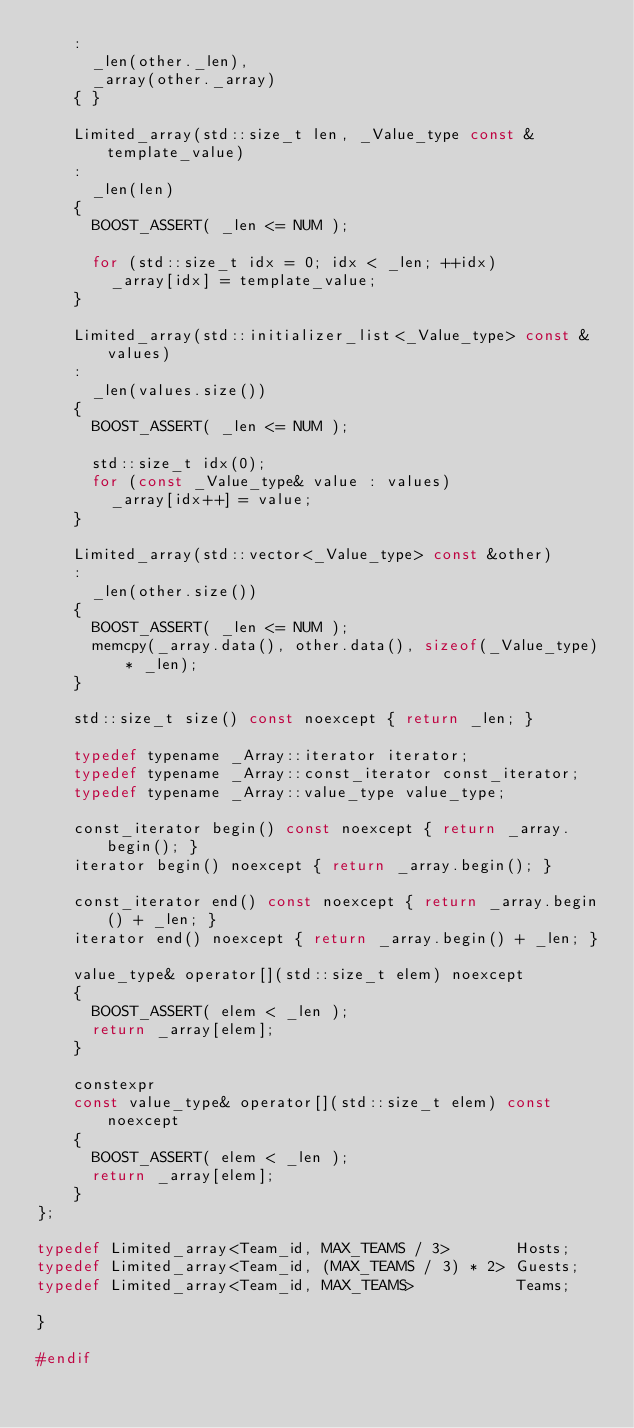Convert code to text. <code><loc_0><loc_0><loc_500><loc_500><_C_>		:
			_len(other._len),
			_array(other._array)
		{ }

		Limited_array(std::size_t len, _Value_type const &template_value)
		:
			_len(len)
		{
			BOOST_ASSERT( _len <= NUM );

			for (std::size_t idx = 0; idx < _len; ++idx)
				_array[idx] = template_value;
		}

		Limited_array(std::initializer_list<_Value_type> const &values)
		:
			_len(values.size())
		{
			BOOST_ASSERT( _len <= NUM );

			std::size_t idx(0);
			for (const _Value_type& value : values)
				_array[idx++] = value;
		}

		Limited_array(std::vector<_Value_type> const &other)
		:
			_len(other.size())
		{
			BOOST_ASSERT( _len <= NUM );
			memcpy(_array.data(), other.data(), sizeof(_Value_type) * _len);
		}

		std::size_t size() const noexcept { return _len; }

		typedef typename _Array::iterator iterator;
		typedef typename _Array::const_iterator const_iterator;
		typedef typename _Array::value_type value_type;

		const_iterator begin() const noexcept { return _array.begin(); }
		iterator begin() noexcept { return _array.begin(); }

		const_iterator end() const noexcept { return _array.begin() + _len; }
		iterator end() noexcept { return _array.begin() + _len; }

		value_type& operator[](std::size_t elem) noexcept
		{
			BOOST_ASSERT( elem < _len );
			return _array[elem];
		}

		constexpr
		const value_type& operator[](std::size_t elem) const noexcept
		{
			BOOST_ASSERT( elem < _len );
			return _array[elem];
		}
};

typedef Limited_array<Team_id, MAX_TEAMS / 3>       Hosts;
typedef Limited_array<Team_id, (MAX_TEAMS / 3) * 2> Guests;
typedef Limited_array<Team_id, MAX_TEAMS>           Teams;

}

#endif
</code> 